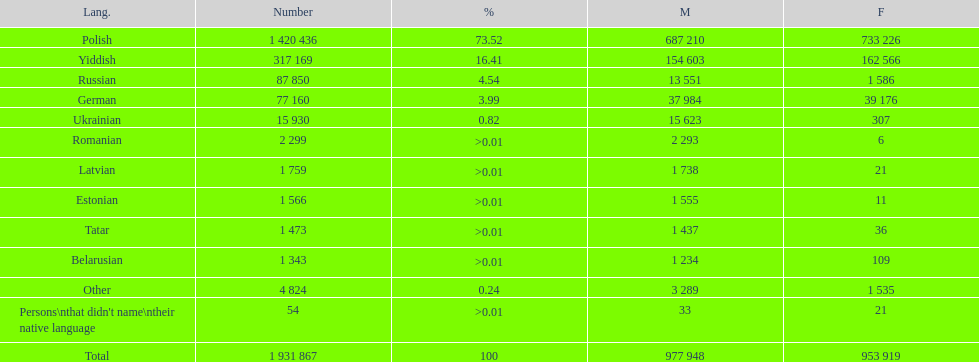Number of male russian speakers 13 551. 